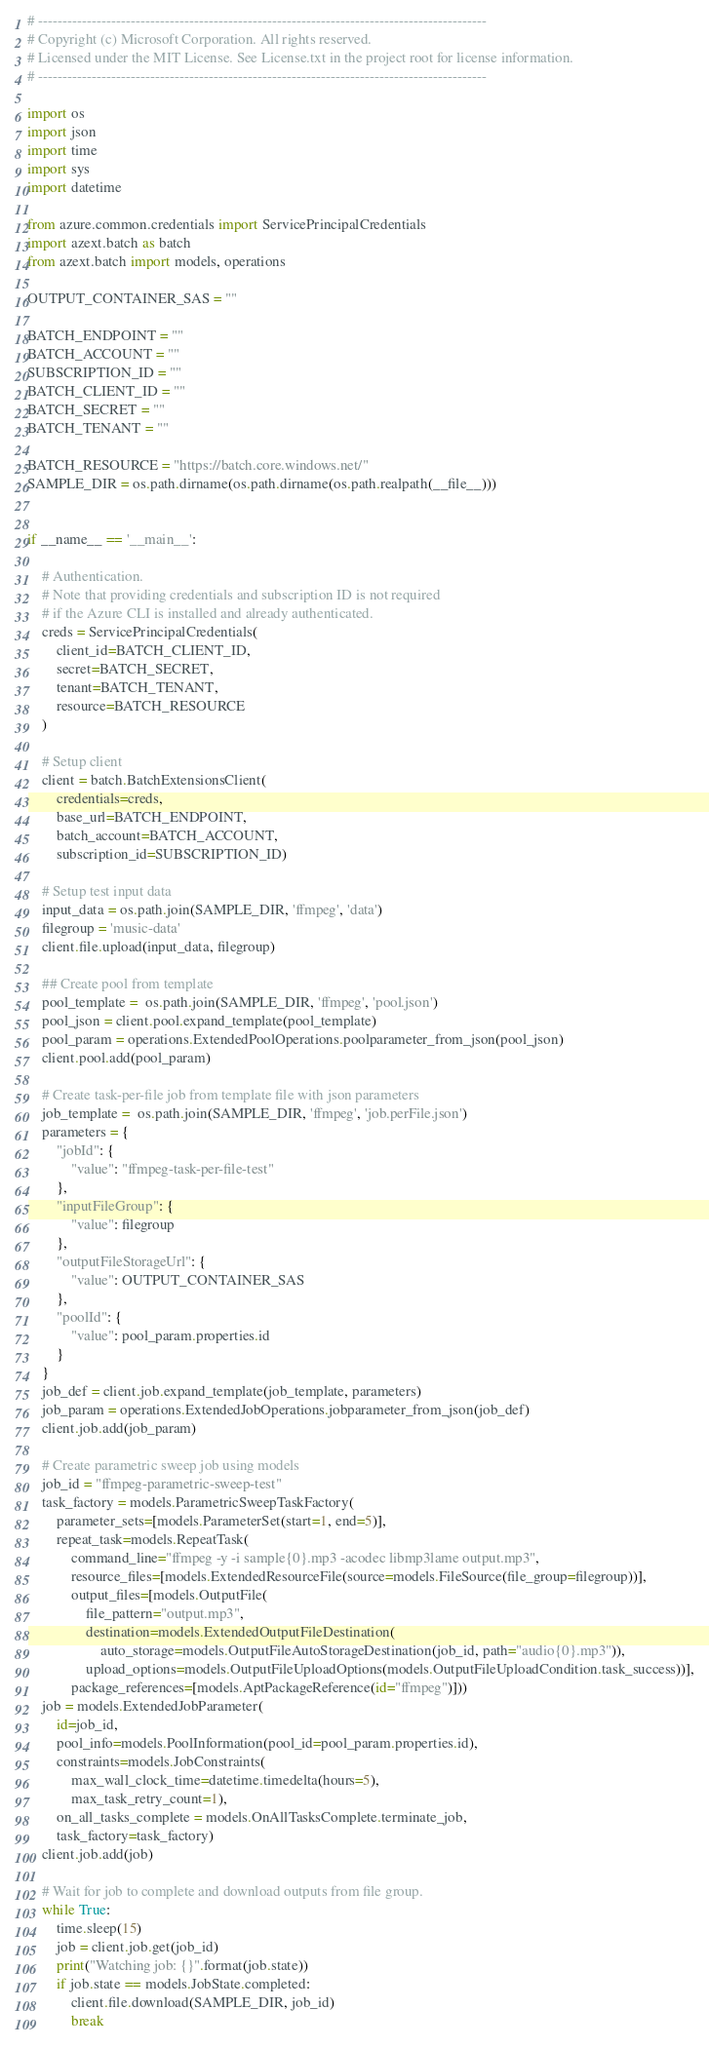<code> <loc_0><loc_0><loc_500><loc_500><_Python_># --------------------------------------------------------------------------------------------
# Copyright (c) Microsoft Corporation. All rights reserved.
# Licensed under the MIT License. See License.txt in the project root for license information.
# --------------------------------------------------------------------------------------------

import os
import json
import time
import sys
import datetime

from azure.common.credentials import ServicePrincipalCredentials
import azext.batch as batch
from azext.batch import models, operations

OUTPUT_CONTAINER_SAS = ""

BATCH_ENDPOINT = ""
BATCH_ACCOUNT = ""
SUBSCRIPTION_ID = ""
BATCH_CLIENT_ID = ""
BATCH_SECRET = ""
BATCH_TENANT = ""

BATCH_RESOURCE = "https://batch.core.windows.net/"
SAMPLE_DIR = os.path.dirname(os.path.dirname(os.path.realpath(__file__)))


if __name__ == '__main__':

    # Authentication.
    # Note that providing credentials and subscription ID is not required
    # if the Azure CLI is installed and already authenticated.
    creds = ServicePrincipalCredentials(
        client_id=BATCH_CLIENT_ID,
        secret=BATCH_SECRET,
        tenant=BATCH_TENANT,
        resource=BATCH_RESOURCE
    )
    
    # Setup client
    client = batch.BatchExtensionsClient(
        credentials=creds,
        base_url=BATCH_ENDPOINT,
        batch_account=BATCH_ACCOUNT,
        subscription_id=SUBSCRIPTION_ID)

    # Setup test input data
    input_data = os.path.join(SAMPLE_DIR, 'ffmpeg', 'data')
    filegroup = 'music-data'
    client.file.upload(input_data, filegroup)

    ## Create pool from template
    pool_template =  os.path.join(SAMPLE_DIR, 'ffmpeg', 'pool.json')
    pool_json = client.pool.expand_template(pool_template)
    pool_param = operations.ExtendedPoolOperations.poolparameter_from_json(pool_json)
    client.pool.add(pool_param)

    # Create task-per-file job from template file with json parameters
    job_template =  os.path.join(SAMPLE_DIR, 'ffmpeg', 'job.perFile.json')
    parameters = {
        "jobId": {
            "value": "ffmpeg-task-per-file-test"
        },
        "inputFileGroup": {
            "value": filegroup
        },  
        "outputFileStorageUrl": {
            "value": OUTPUT_CONTAINER_SAS
        },
        "poolId": {
            "value": pool_param.properties.id
        }
    }
    job_def = client.job.expand_template(job_template, parameters)
    job_param = operations.ExtendedJobOperations.jobparameter_from_json(job_def)
    client.job.add(job_param)

    # Create parametric sweep job using models
    job_id = "ffmpeg-parametric-sweep-test"
    task_factory = models.ParametricSweepTaskFactory(
        parameter_sets=[models.ParameterSet(start=1, end=5)],
        repeat_task=models.RepeatTask(
            command_line="ffmpeg -y -i sample{0}.mp3 -acodec libmp3lame output.mp3",
            resource_files=[models.ExtendedResourceFile(source=models.FileSource(file_group=filegroup))],
            output_files=[models.OutputFile(
                file_pattern="output.mp3",
                destination=models.ExtendedOutputFileDestination(
                    auto_storage=models.OutputFileAutoStorageDestination(job_id, path="audio{0}.mp3")),
                upload_options=models.OutputFileUploadOptions(models.OutputFileUploadCondition.task_success))],
            package_references=[models.AptPackageReference(id="ffmpeg")]))
    job = models.ExtendedJobParameter(
        id=job_id,
        pool_info=models.PoolInformation(pool_id=pool_param.properties.id),
        constraints=models.JobConstraints(
            max_wall_clock_time=datetime.timedelta(hours=5),
            max_task_retry_count=1),
        on_all_tasks_complete = models.OnAllTasksComplete.terminate_job,
        task_factory=task_factory)
    client.job.add(job)

    # Wait for job to complete and download outputs from file group.
    while True:
        time.sleep(15)
        job = client.job.get(job_id)
        print("Watching job: {}".format(job.state))
        if job.state == models.JobState.completed:
            client.file.download(SAMPLE_DIR, job_id)
            break
</code> 